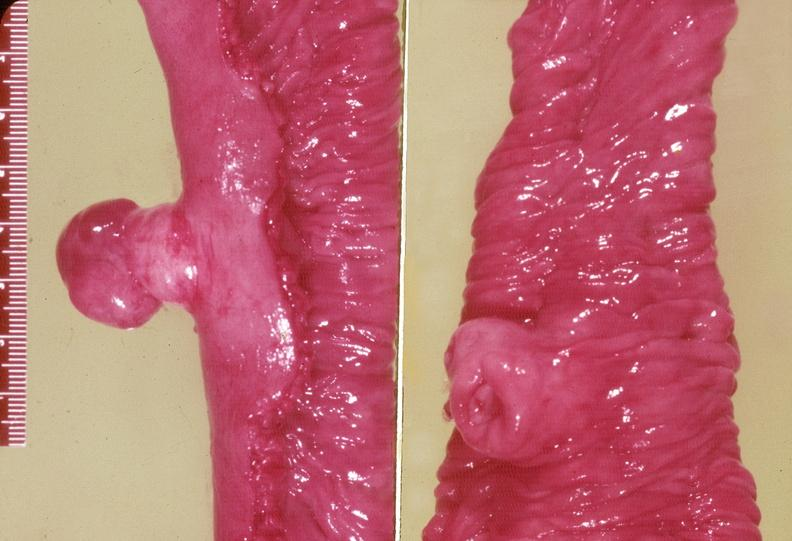does a bulge show gejunum, leiomyoma?
Answer the question using a single word or phrase. No 